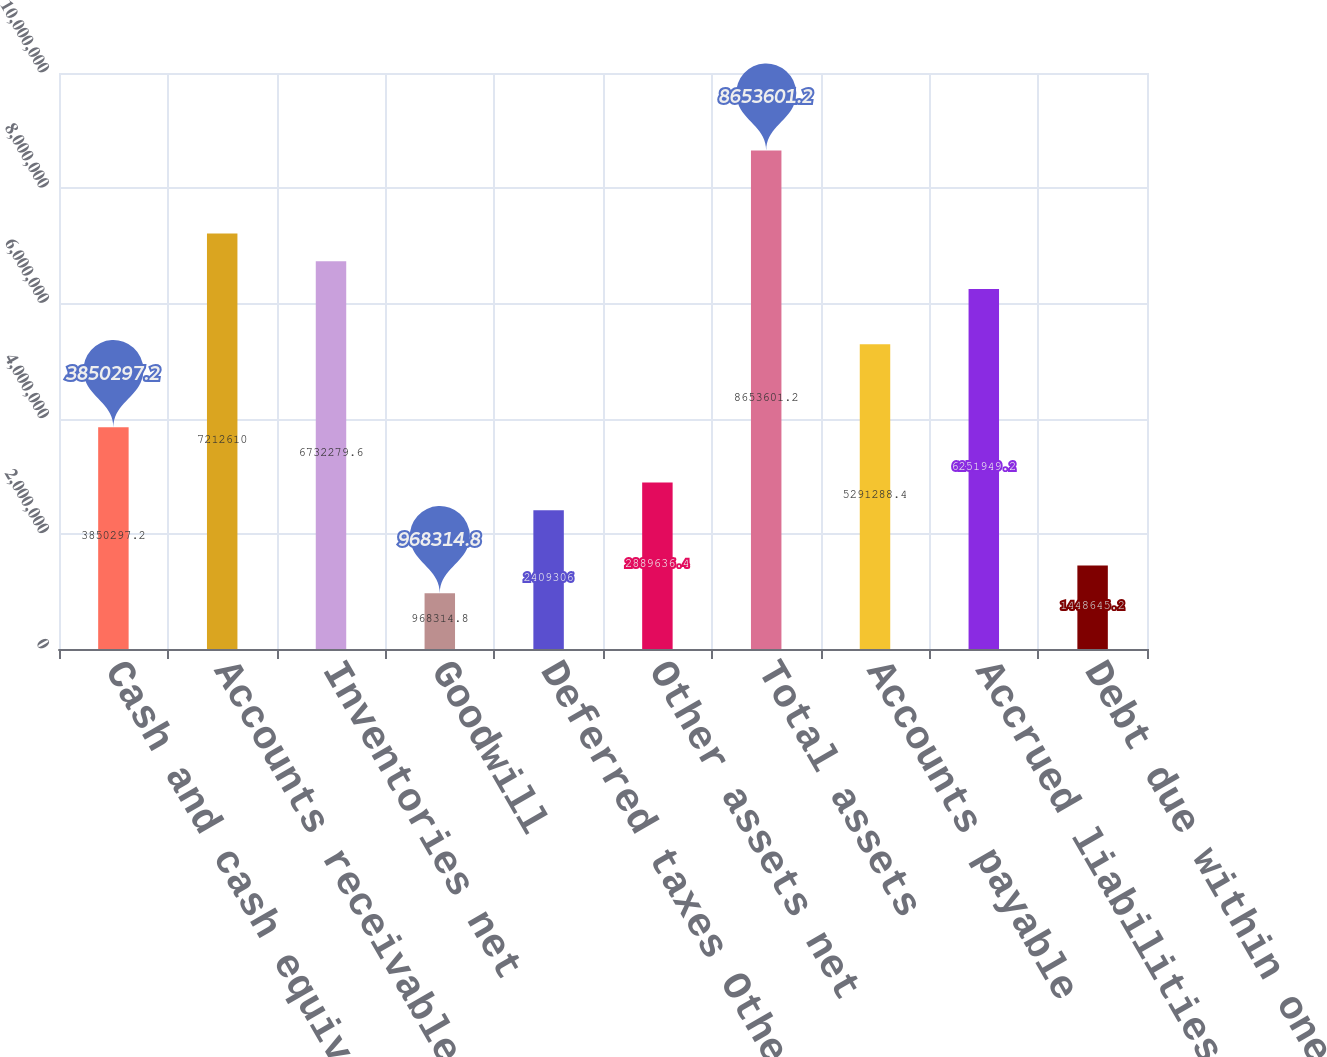<chart> <loc_0><loc_0><loc_500><loc_500><bar_chart><fcel>Cash and cash equivalents<fcel>Accounts receivable net<fcel>Inventories net<fcel>Goodwill<fcel>Deferred taxes Other<fcel>Other assets net<fcel>Total assets<fcel>Accounts payable<fcel>Accrued liabilities<fcel>Debt due within one year<nl><fcel>3.8503e+06<fcel>7.21261e+06<fcel>6.73228e+06<fcel>968315<fcel>2.40931e+06<fcel>2.88964e+06<fcel>8.6536e+06<fcel>5.29129e+06<fcel>6.25195e+06<fcel>1.44865e+06<nl></chart> 